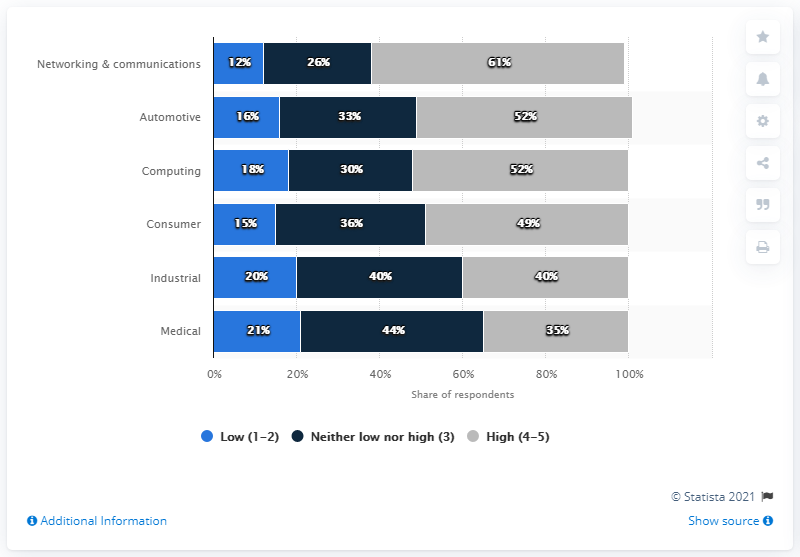Identify some key points in this picture. The study found that the percentage of respondents who reported experiencing harassment or discrimination varied greatly between industries, with some industries having a lower share of respondents reporting these experiences and others having a higher share. In the survey, 44% of the respondents were in the medical field. 